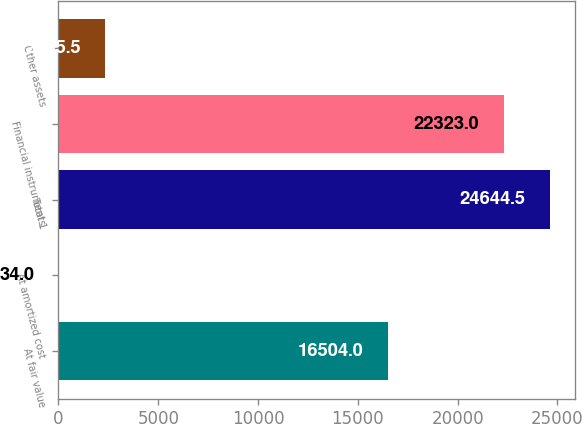Convert chart. <chart><loc_0><loc_0><loc_500><loc_500><bar_chart><fcel>At fair value<fcel>At amortized cost<fcel>Total 1<fcel>Financial instruments<fcel>Other assets<nl><fcel>16504<fcel>34<fcel>24644.5<fcel>22323<fcel>2355.5<nl></chart> 